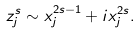Convert formula to latex. <formula><loc_0><loc_0><loc_500><loc_500>z ^ { s } _ { j } \sim x _ { j } ^ { 2 s - 1 } + i x _ { j } ^ { 2 s } .</formula> 